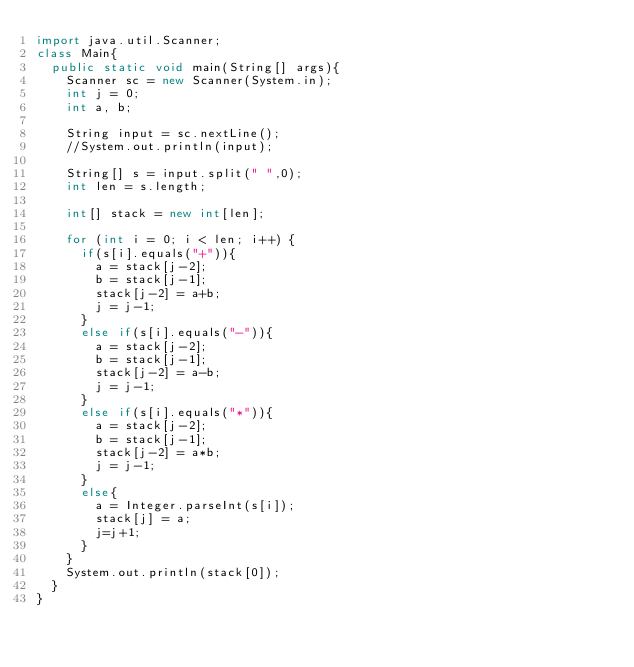<code> <loc_0><loc_0><loc_500><loc_500><_Java_>import java.util.Scanner;
class Main{
  public static void main(String[] args){
    Scanner sc = new Scanner(System.in);
    int j = 0;
    int a, b;

    String input = sc.nextLine();
    //System.out.println(input);

    String[] s = input.split(" ",0);
    int len = s.length;

    int[] stack = new int[len];

    for (int i = 0; i < len; i++) {
      if(s[i].equals("+")){
        a = stack[j-2];
        b = stack[j-1];
        stack[j-2] = a+b;
        j = j-1;
      }
      else if(s[i].equals("-")){
        a = stack[j-2];
        b = stack[j-1];
        stack[j-2] = a-b;
        j = j-1;
      }
      else if(s[i].equals("*")){
        a = stack[j-2];
        b = stack[j-1];
        stack[j-2] = a*b;
        j = j-1;
      }
      else{
        a = Integer.parseInt(s[i]);
        stack[j] = a;
        j=j+1;
      }
    }
    System.out.println(stack[0]);
  }
}
</code> 